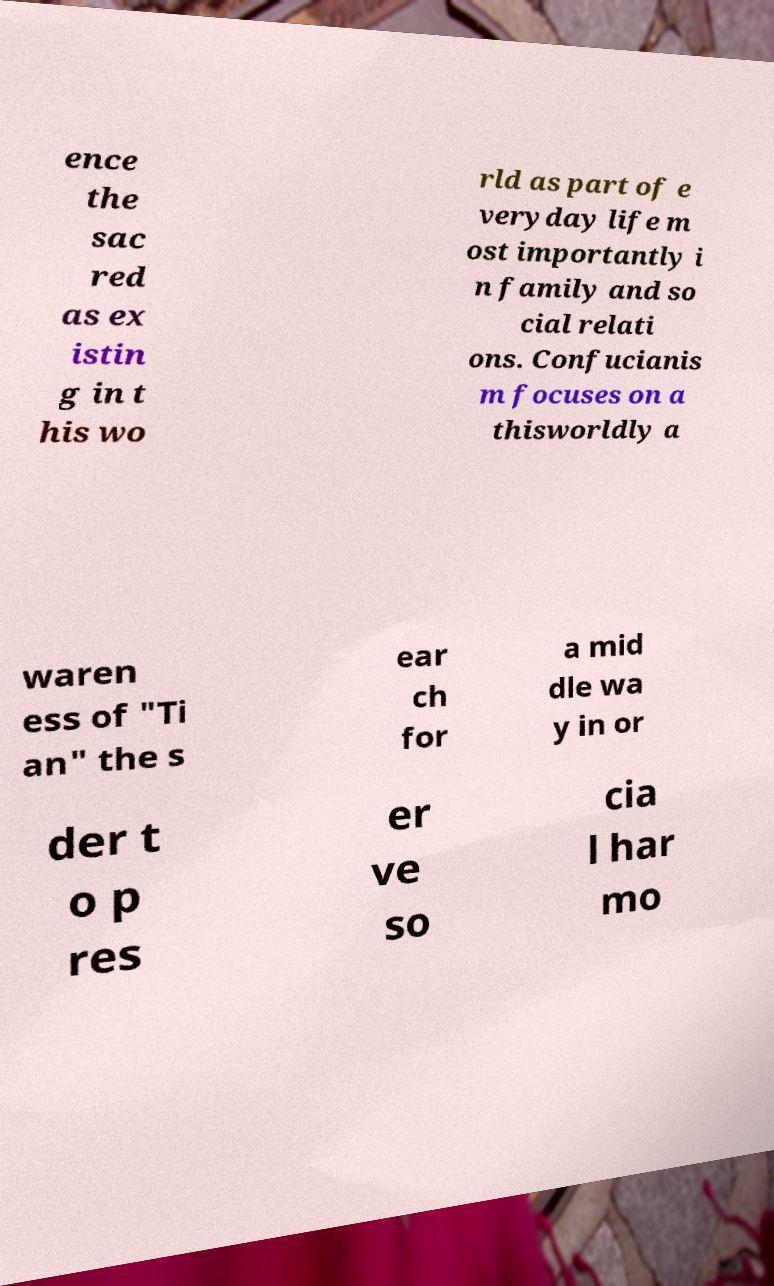Could you assist in decoding the text presented in this image and type it out clearly? ence the sac red as ex istin g in t his wo rld as part of e veryday life m ost importantly i n family and so cial relati ons. Confucianis m focuses on a thisworldly a waren ess of "Ti an" the s ear ch for a mid dle wa y in or der t o p res er ve so cia l har mo 